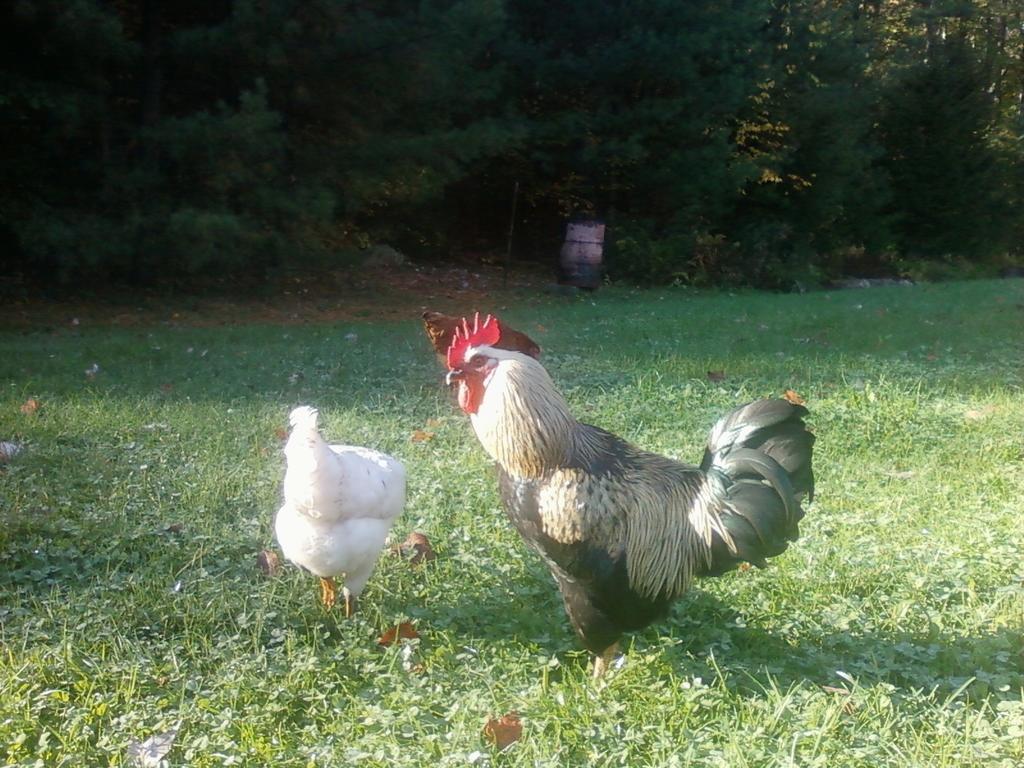Please provide a concise description of this image. In this picture there is a cock in the center of the image and there are two hens on the left side of the image, there is grassland at the bottom side of the image and there are trees at the top side of the image. 